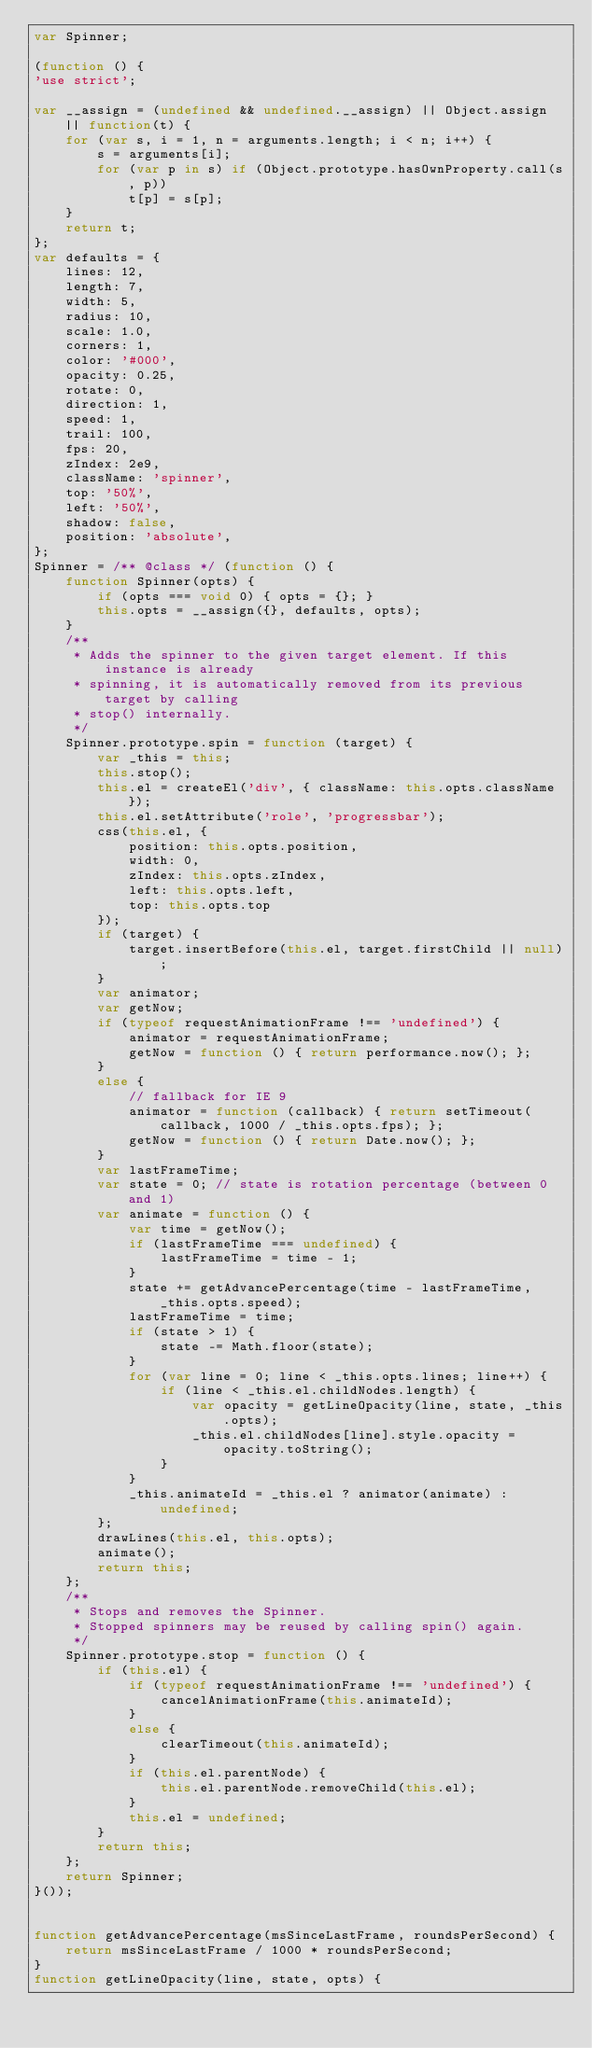<code> <loc_0><loc_0><loc_500><loc_500><_JavaScript_>var Spinner;

(function () {
'use strict';

var __assign = (undefined && undefined.__assign) || Object.assign || function(t) {
    for (var s, i = 1, n = arguments.length; i < n; i++) {
        s = arguments[i];
        for (var p in s) if (Object.prototype.hasOwnProperty.call(s, p))
            t[p] = s[p];
    }
    return t;
};
var defaults = {
    lines: 12,
    length: 7,
    width: 5,
    radius: 10,
    scale: 1.0,
    corners: 1,
    color: '#000',
    opacity: 0.25,
    rotate: 0,
    direction: 1,
    speed: 1,
    trail: 100,
    fps: 20,
    zIndex: 2e9,
    className: 'spinner',
    top: '50%',
    left: '50%',
    shadow: false,
    position: 'absolute',
};
Spinner = /** @class */ (function () {
    function Spinner(opts) {
        if (opts === void 0) { opts = {}; }
        this.opts = __assign({}, defaults, opts);
    }
    /**
     * Adds the spinner to the given target element. If this instance is already
     * spinning, it is automatically removed from its previous target by calling
     * stop() internally.
     */
    Spinner.prototype.spin = function (target) {
        var _this = this;
        this.stop();
        this.el = createEl('div', { className: this.opts.className });
        this.el.setAttribute('role', 'progressbar');
        css(this.el, {
            position: this.opts.position,
            width: 0,
            zIndex: this.opts.zIndex,
            left: this.opts.left,
            top: this.opts.top
        });
        if (target) {
            target.insertBefore(this.el, target.firstChild || null);
        }
        var animator;
        var getNow;
        if (typeof requestAnimationFrame !== 'undefined') {
            animator = requestAnimationFrame;
            getNow = function () { return performance.now(); };
        }
        else {
            // fallback for IE 9
            animator = function (callback) { return setTimeout(callback, 1000 / _this.opts.fps); };
            getNow = function () { return Date.now(); };
        }
        var lastFrameTime;
        var state = 0; // state is rotation percentage (between 0 and 1)
        var animate = function () {
            var time = getNow();
            if (lastFrameTime === undefined) {
                lastFrameTime = time - 1;
            }
            state += getAdvancePercentage(time - lastFrameTime, _this.opts.speed);
            lastFrameTime = time;
            if (state > 1) {
                state -= Math.floor(state);
            }
            for (var line = 0; line < _this.opts.lines; line++) {
                if (line < _this.el.childNodes.length) {
                    var opacity = getLineOpacity(line, state, _this.opts);
                    _this.el.childNodes[line].style.opacity = opacity.toString();
                }
            }
            _this.animateId = _this.el ? animator(animate) : undefined;
        };
        drawLines(this.el, this.opts);
        animate();
        return this;
    };
    /**
     * Stops and removes the Spinner.
     * Stopped spinners may be reused by calling spin() again.
     */
    Spinner.prototype.stop = function () {
        if (this.el) {
            if (typeof requestAnimationFrame !== 'undefined') {
                cancelAnimationFrame(this.animateId);
            }
            else {
                clearTimeout(this.animateId);
            }
            if (this.el.parentNode) {
                this.el.parentNode.removeChild(this.el);
            }
            this.el = undefined;
        }
        return this;
    };
    return Spinner;
}());


function getAdvancePercentage(msSinceLastFrame, roundsPerSecond) {
    return msSinceLastFrame / 1000 * roundsPerSecond;
}
function getLineOpacity(line, state, opts) {</code> 